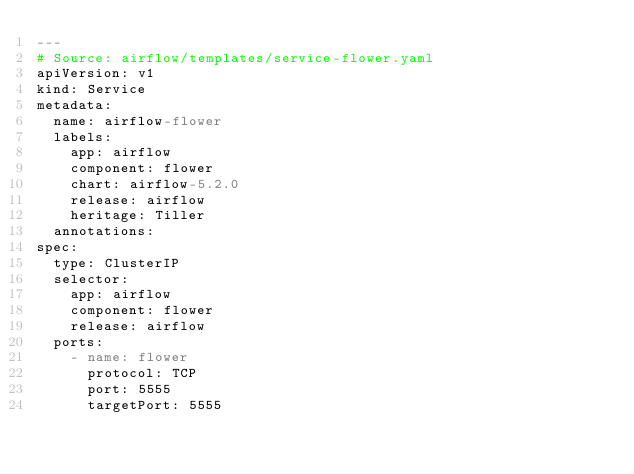Convert code to text. <code><loc_0><loc_0><loc_500><loc_500><_YAML_>---
# Source: airflow/templates/service-flower.yaml
apiVersion: v1
kind: Service
metadata:
  name: airflow-flower
  labels:
    app: airflow
    component: flower
    chart: airflow-5.2.0
    release: airflow
    heritage: Tiller
  annotations:
spec:
  type: ClusterIP
  selector:
    app: airflow
    component: flower
    release: airflow
  ports:
    - name: flower
      protocol: TCP
      port: 5555
      targetPort: 5555
</code> 